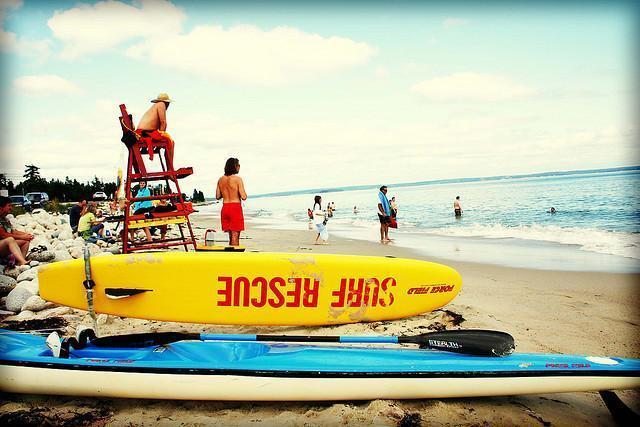How many cows are walking in the road?
Give a very brief answer. 0. 